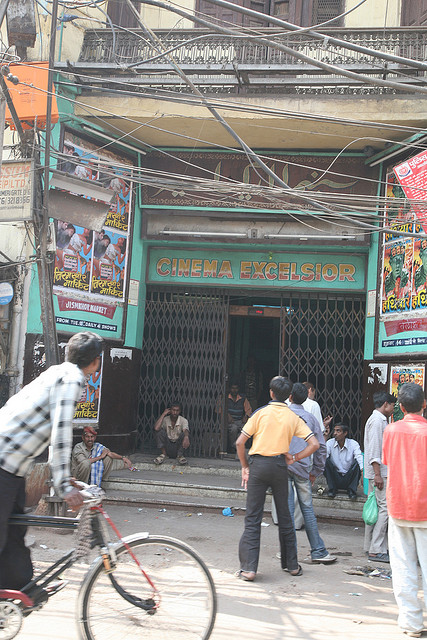Can you tell me more about the cinema entrance? Certainly! The entrance to 'CINEMA EXCELSIOR' stands out with its vibrant green paint and metal grill gate, giving it a vintage charm. Above the entrance, there's a haphazard web of electrical wires, indicative of the dense urban setting. The faded walls and the style of the posters hint at the cinema’s longstanding presence in the area, likely serving as a staple entertainment venue for the local community. 